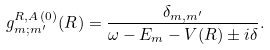Convert formula to latex. <formula><loc_0><loc_0><loc_500><loc_500>g _ { m ; m ^ { \prime } } ^ { R , A \, ( 0 ) } ( { R } ) = \frac { \delta _ { m , m ^ { \prime } } } { \omega - E _ { m } - V ( { R } ) \pm i \delta } .</formula> 